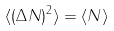<formula> <loc_0><loc_0><loc_500><loc_500>\langle ( \Delta N ) ^ { 2 } \rangle = \langle N \rangle</formula> 